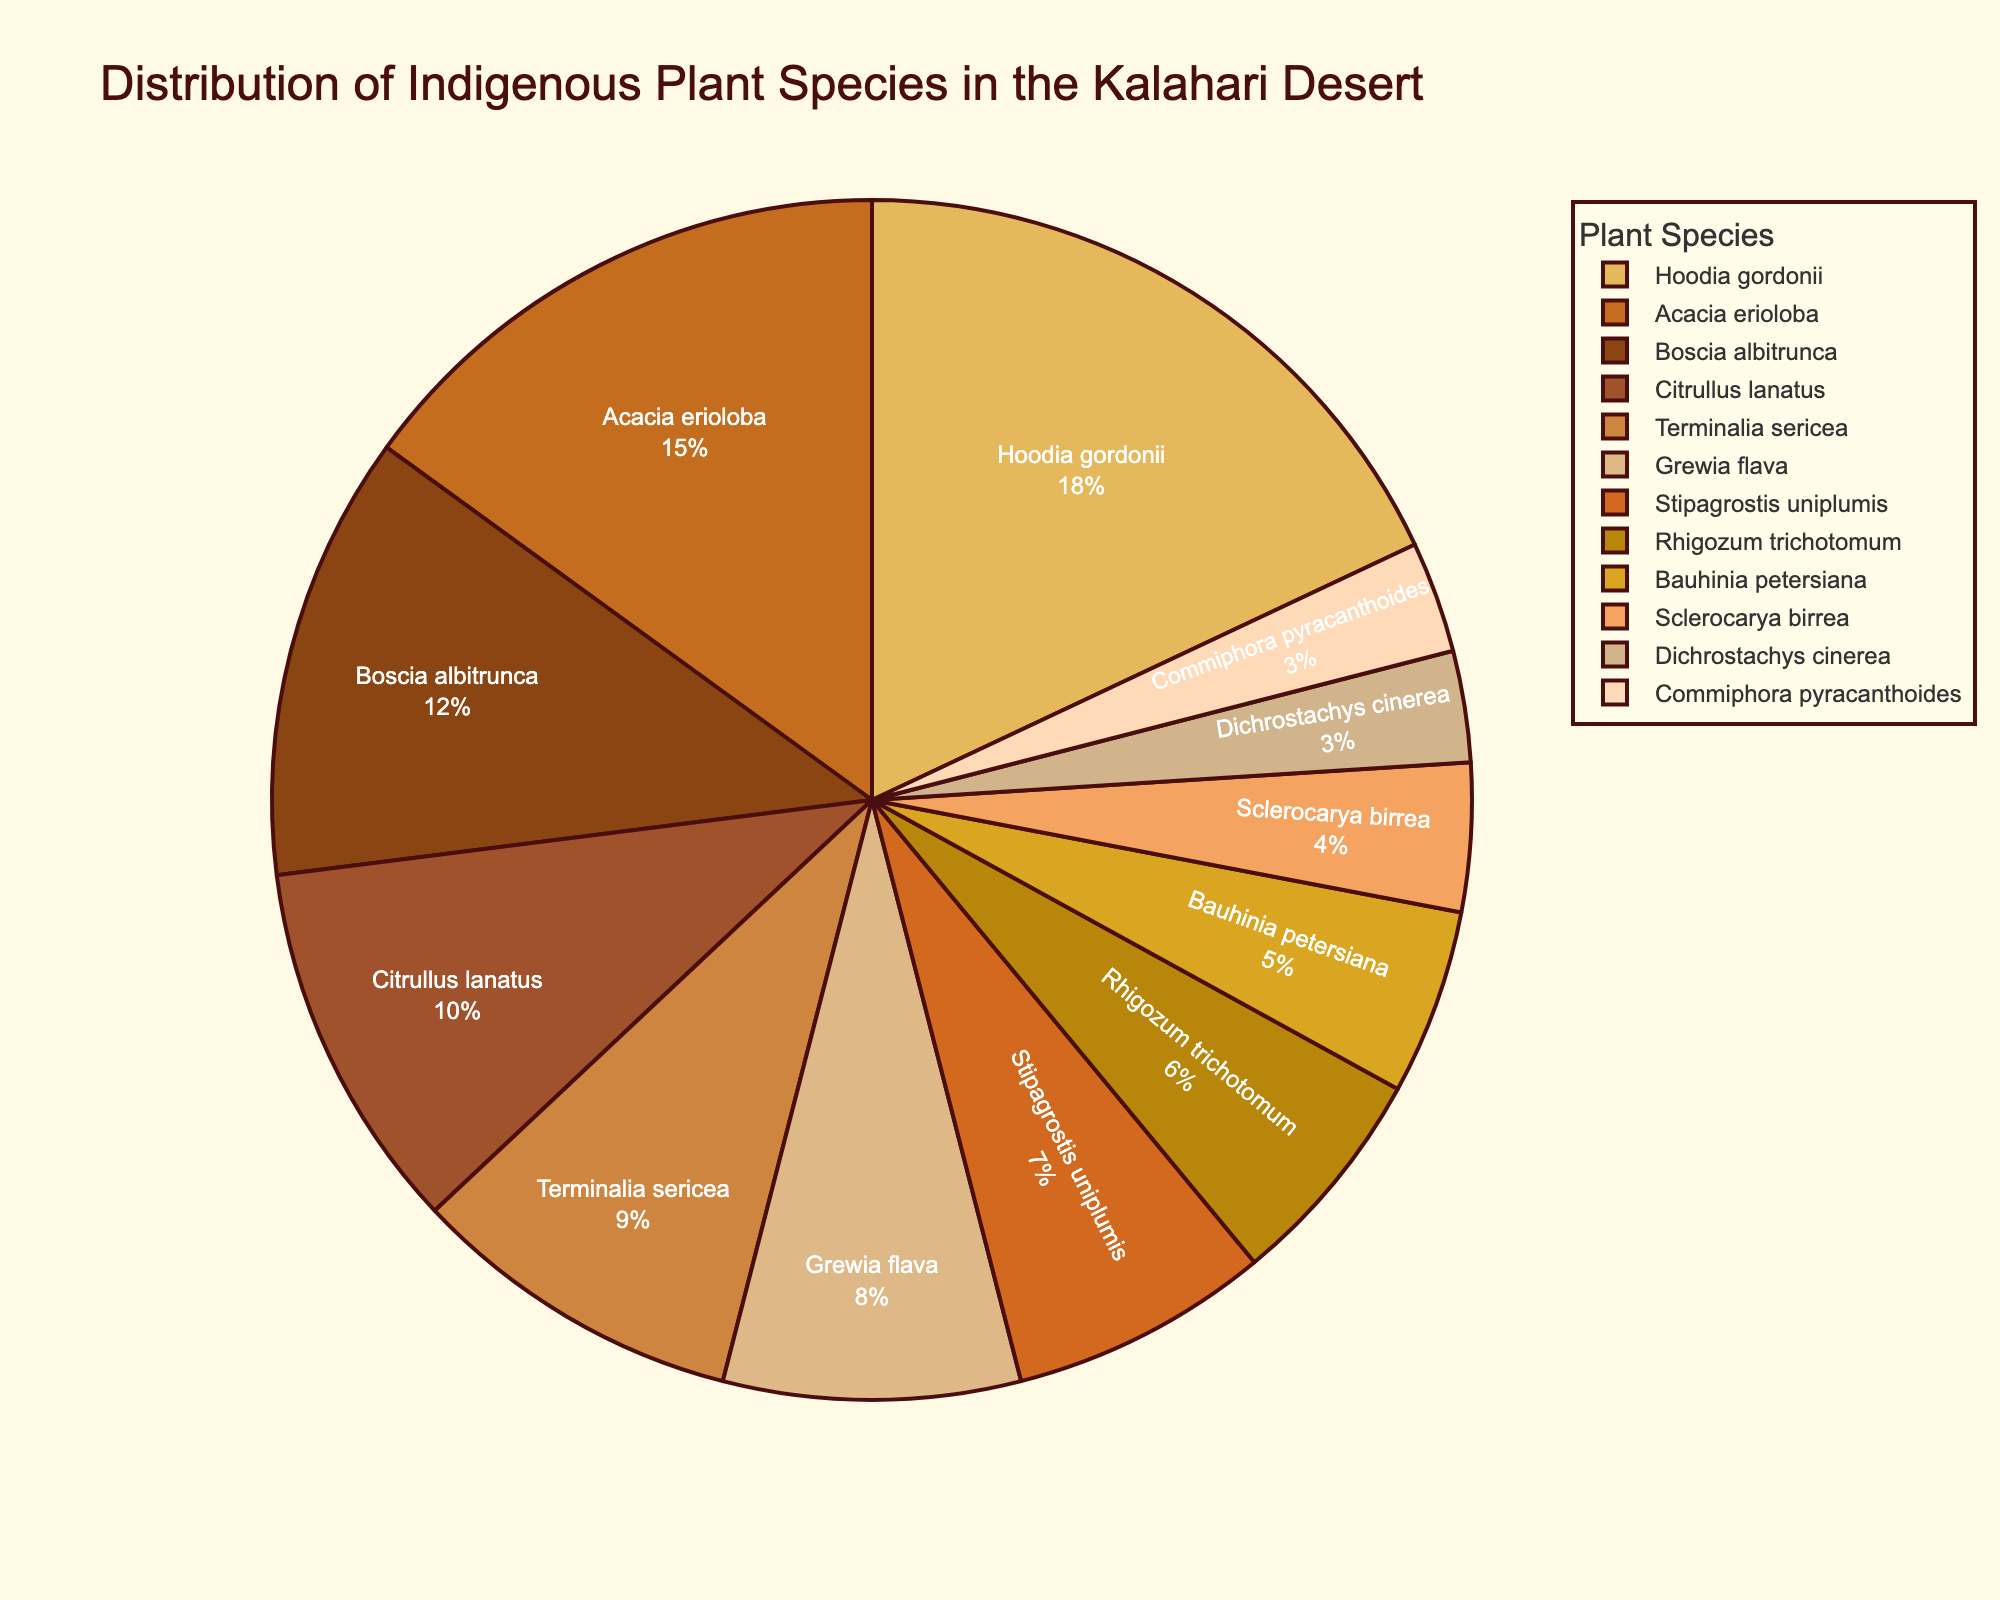How many more species does Hoodia gordonii have compared to Bauhinia petersiana? First, find the percentages for Hoodia gordonii (18%) and Bauhinia petersiana (5%). Then subtract the percentage of Bauhinia petersiana from Hoodia gordonii (18 - 5).
Answer: 13% Which plant species has the smallest proportion in the distribution? Find the species with the smallest percentage value in the pie chart. Here, it is either Dichrostachys cinerea or Commiphora pyracanthoides, both at 3%.
Answer: Dichrostachys cinerea / Commiphora pyracanthoides Is the combined percentage of Acacia erioloba and Boscia albitrunca greater than or equal to Hoodia gordonii? Sum the percentages of Acacia erioloba (15%) and Boscia albitrunca (12%), which gives 27%. Compare this with Hoodia gordonii's percentage of 18%. (27 >= 18).
Answer: Yes How many species have a percentage within the range of 5% to 10%? Count the number of species whose percentages fall within the range of 5% to 10%. These are Terminalia sericea (9%), Grewia flava (8%), Stipagrostis uniplumis (7%), Rhigozum trichotomum (6%), and Bauhinia petersiana (5%).
Answer: 5 What is the total percentage of species that are greater than 10%? Identify species with percentages greater than 10%: Hoodia gordonii (18%), Acacia erioloba (15%), and Boscia albitrunca (12%). Sum these percentages (18 + 15 + 12).
Answer: 45% Which species is represented by the darkest shade in the pie chart? By looking at the color palette provided and the visual representation on the pie chart, the species with the darkest shade is likely to be the first or second species, typically Hoodia gordonii or Acacia erioloba.
Answer: Hoodia gordonii What is the average percentage of the plant species listed? Sum the percentages of all plant species (18 + 15 + 12 + 10 + 9 + 8 + 7 + 6 + 5 + 4 + 3 + 3) which equals 100. Divide this sum by the number of species, which is 12.
Answer: 8.33% Does the cumulative percentage of the three least represented species exceed the percentage of Citrullus lanatus alone? Sum the percentages of the three least represented species: Sclerocarya birrea (4%), Dichrostachys cinerea (3%), and Commiphora pyracanthoides (3%) which gives 10%. Compare this with Citrullus lanatus's percentage (10%).
Answer: No How does the percentage of Citrullus lanatus compare to Acacia erioloba? Compare the percentage values for both species: Acacia erioloba (15%) and Citrullus lanatus (10%). Determine which one is greater or by how much.
Answer: Acacia erioloba is higher by 5% 